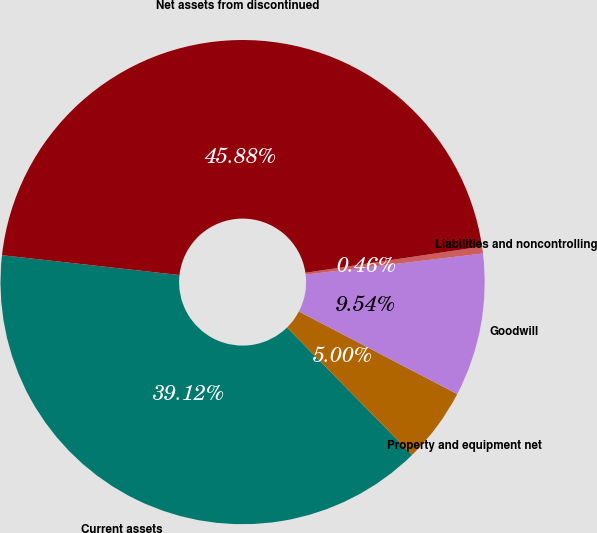Convert chart to OTSL. <chart><loc_0><loc_0><loc_500><loc_500><pie_chart><fcel>Current assets<fcel>Property and equipment net<fcel>Goodwill<fcel>Liabilities and noncontrolling<fcel>Net assets from discontinued<nl><fcel>39.12%<fcel>5.0%<fcel>9.54%<fcel>0.46%<fcel>45.88%<nl></chart> 